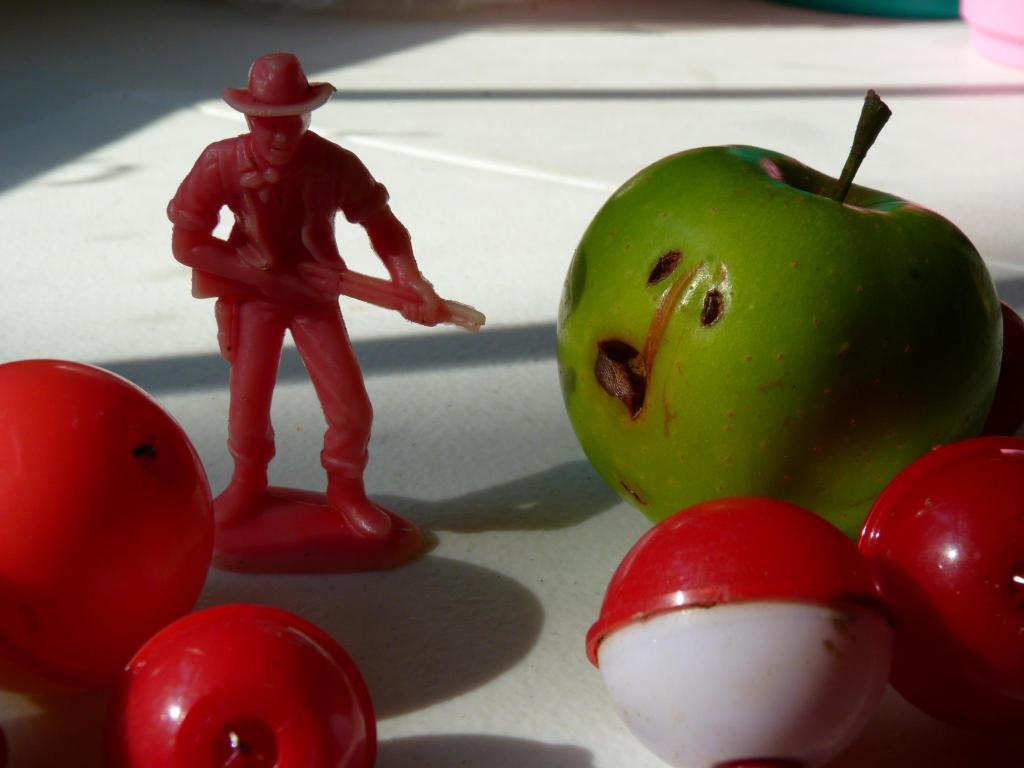How would you summarize this image in a sentence or two? In this image we can see a depictions of a person. There are balls. There is a fruit on the table. 